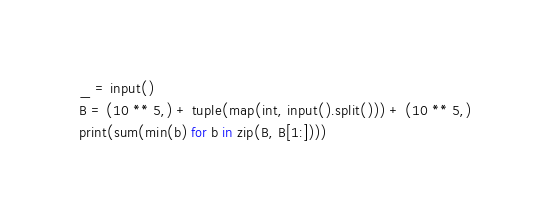<code> <loc_0><loc_0><loc_500><loc_500><_Python_>_ = input()
B = (10 ** 5,) + tuple(map(int, input().split())) + (10 ** 5,)
print(sum(min(b) for b in zip(B, B[1:])))</code> 